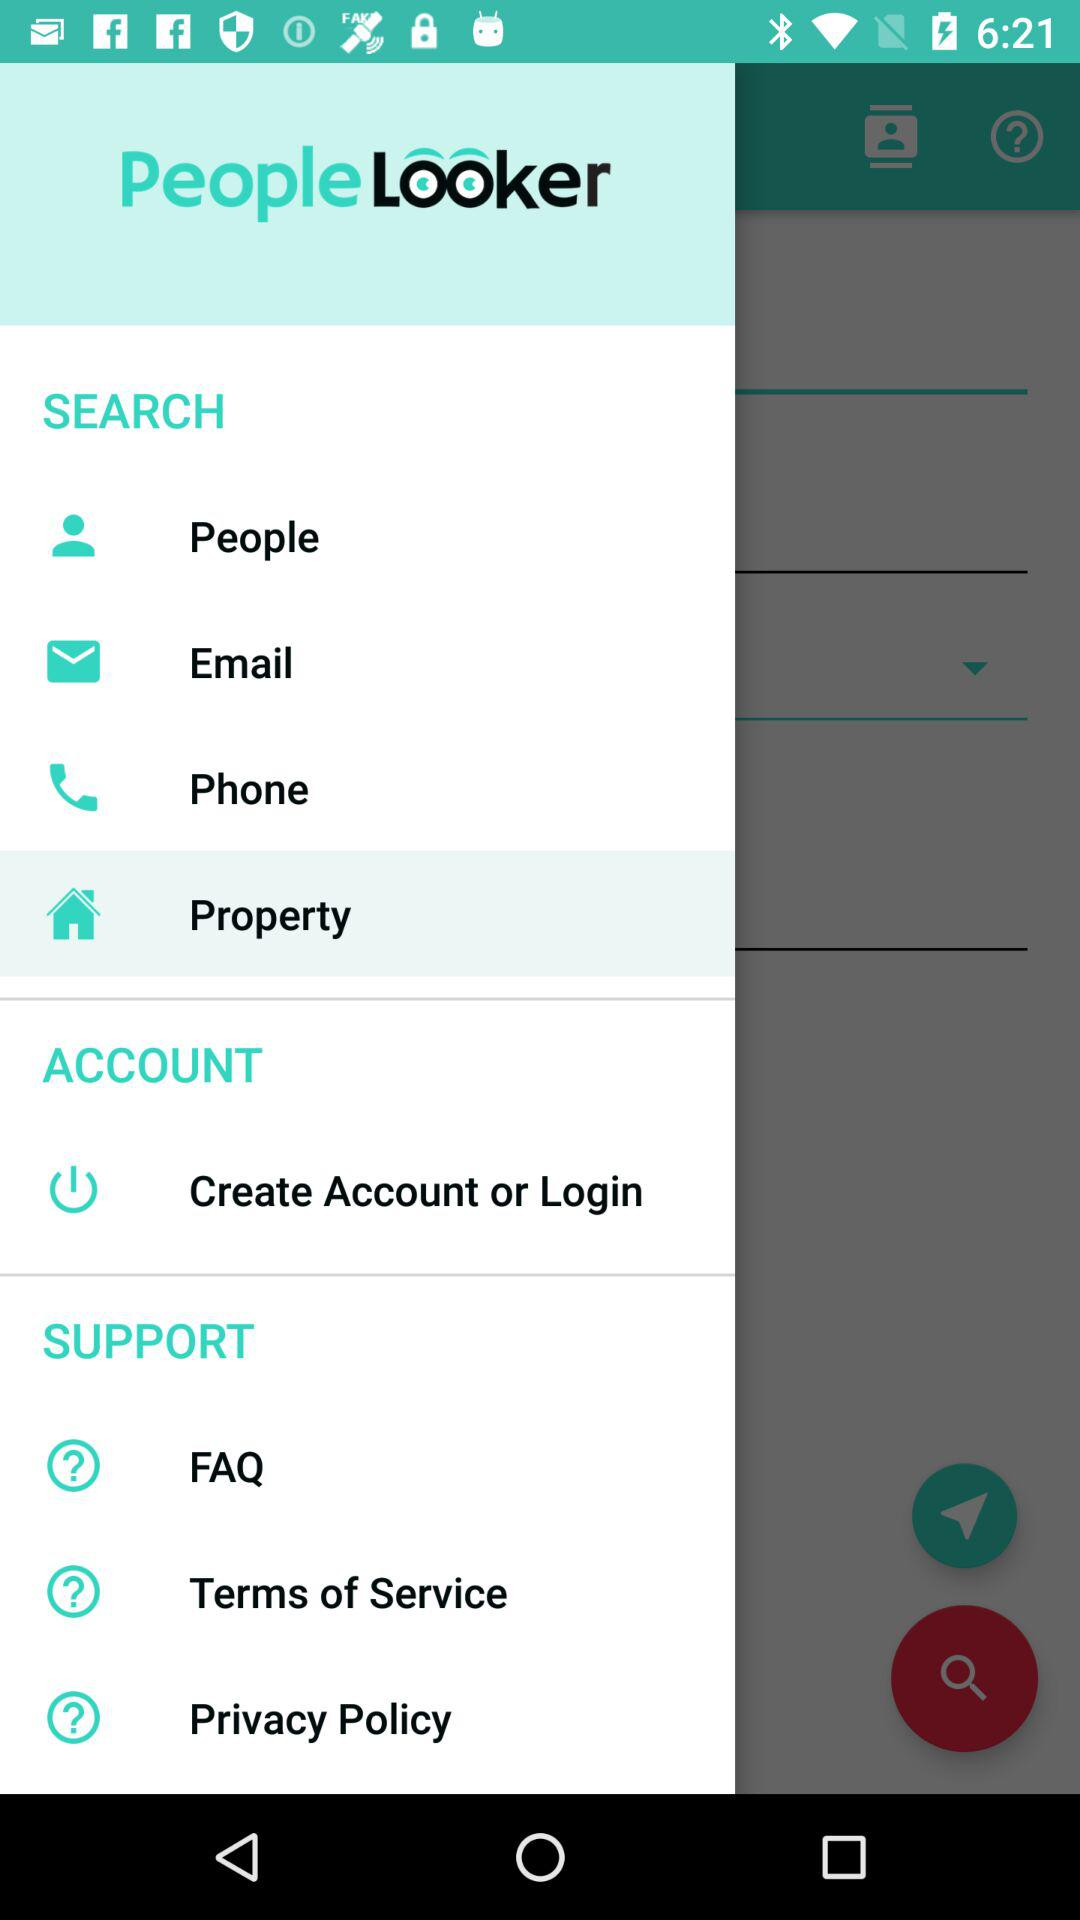Which item is selected? The selected item is "Property". 